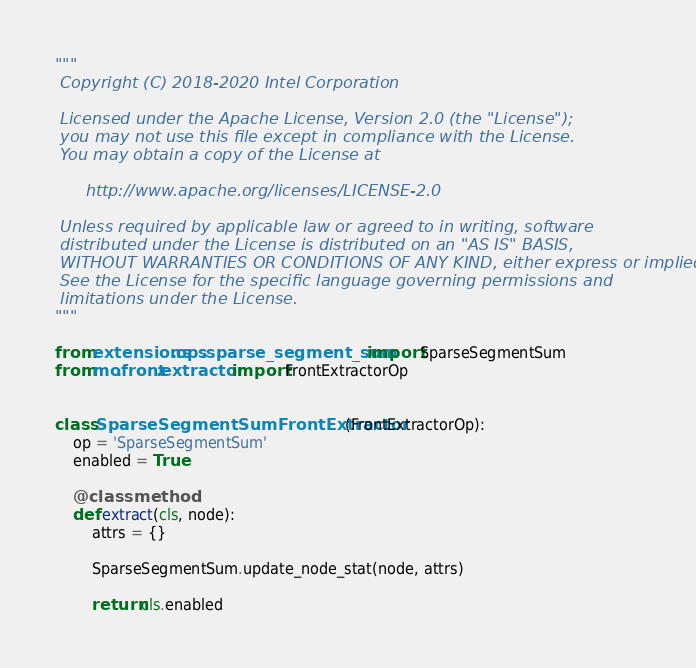Convert code to text. <code><loc_0><loc_0><loc_500><loc_500><_Python_>"""
 Copyright (C) 2018-2020 Intel Corporation

 Licensed under the Apache License, Version 2.0 (the "License");
 you may not use this file except in compliance with the License.
 You may obtain a copy of the License at

      http://www.apache.org/licenses/LICENSE-2.0

 Unless required by applicable law or agreed to in writing, software
 distributed under the License is distributed on an "AS IS" BASIS,
 WITHOUT WARRANTIES OR CONDITIONS OF ANY KIND, either express or implied.
 See the License for the specific language governing permissions and
 limitations under the License.
"""

from extensions.ops.sparse_segment_sum import SparseSegmentSum
from mo.front.extractor import FrontExtractorOp


class SparseSegmentSumFrontExtractor(FrontExtractorOp):
    op = 'SparseSegmentSum'
    enabled = True

    @classmethod
    def extract(cls, node):
        attrs = {}

        SparseSegmentSum.update_node_stat(node, attrs)

        return cls.enabled
</code> 